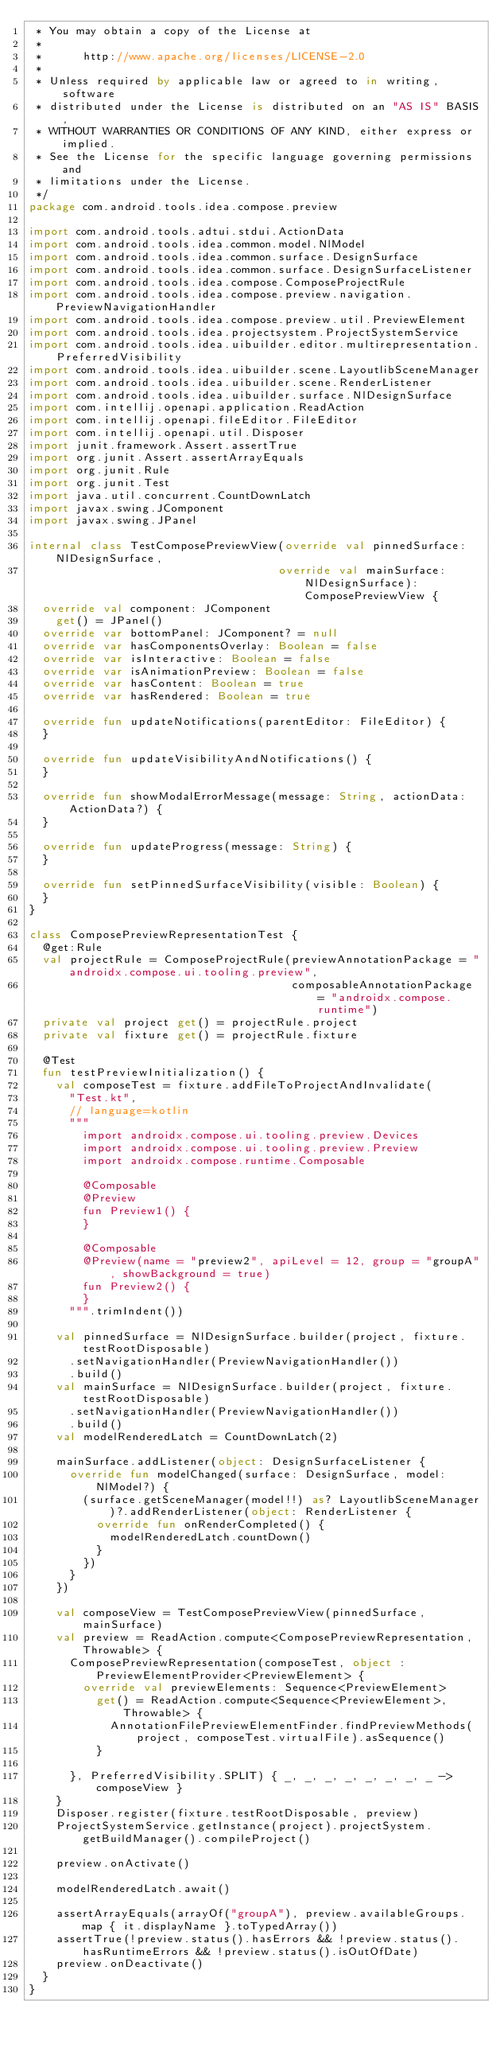Convert code to text. <code><loc_0><loc_0><loc_500><loc_500><_Kotlin_> * You may obtain a copy of the License at
 *
 *      http://www.apache.org/licenses/LICENSE-2.0
 *
 * Unless required by applicable law or agreed to in writing, software
 * distributed under the License is distributed on an "AS IS" BASIS,
 * WITHOUT WARRANTIES OR CONDITIONS OF ANY KIND, either express or implied.
 * See the License for the specific language governing permissions and
 * limitations under the License.
 */
package com.android.tools.idea.compose.preview

import com.android.tools.adtui.stdui.ActionData
import com.android.tools.idea.common.model.NlModel
import com.android.tools.idea.common.surface.DesignSurface
import com.android.tools.idea.common.surface.DesignSurfaceListener
import com.android.tools.idea.compose.ComposeProjectRule
import com.android.tools.idea.compose.preview.navigation.PreviewNavigationHandler
import com.android.tools.idea.compose.preview.util.PreviewElement
import com.android.tools.idea.projectsystem.ProjectSystemService
import com.android.tools.idea.uibuilder.editor.multirepresentation.PreferredVisibility
import com.android.tools.idea.uibuilder.scene.LayoutlibSceneManager
import com.android.tools.idea.uibuilder.scene.RenderListener
import com.android.tools.idea.uibuilder.surface.NlDesignSurface
import com.intellij.openapi.application.ReadAction
import com.intellij.openapi.fileEditor.FileEditor
import com.intellij.openapi.util.Disposer
import junit.framework.Assert.assertTrue
import org.junit.Assert.assertArrayEquals
import org.junit.Rule
import org.junit.Test
import java.util.concurrent.CountDownLatch
import javax.swing.JComponent
import javax.swing.JPanel

internal class TestComposePreviewView(override val pinnedSurface: NlDesignSurface,
                                     override val mainSurface: NlDesignSurface): ComposePreviewView {
  override val component: JComponent
    get() = JPanel()
  override var bottomPanel: JComponent? = null
  override var hasComponentsOverlay: Boolean = false
  override var isInteractive: Boolean = false
  override var isAnimationPreview: Boolean = false
  override var hasContent: Boolean = true
  override var hasRendered: Boolean = true

  override fun updateNotifications(parentEditor: FileEditor) {
  }

  override fun updateVisibilityAndNotifications() {
  }

  override fun showModalErrorMessage(message: String, actionData: ActionData?) {
  }

  override fun updateProgress(message: String) {
  }

  override fun setPinnedSurfaceVisibility(visible: Boolean) {
  }
}

class ComposePreviewRepresentationTest {
  @get:Rule
  val projectRule = ComposeProjectRule(previewAnnotationPackage = "androidx.compose.ui.tooling.preview",
                                       composableAnnotationPackage = "androidx.compose.runtime")
  private val project get() = projectRule.project
  private val fixture get() = projectRule.fixture

  @Test
  fun testPreviewInitialization() {
    val composeTest = fixture.addFileToProjectAndInvalidate(
      "Test.kt",
      // language=kotlin
      """
        import androidx.compose.ui.tooling.preview.Devices
        import androidx.compose.ui.tooling.preview.Preview
        import androidx.compose.runtime.Composable

        @Composable
        @Preview
        fun Preview1() {
        }

        @Composable
        @Preview(name = "preview2", apiLevel = 12, group = "groupA", showBackground = true)
        fun Preview2() {
        }
      """.trimIndent())

    val pinnedSurface = NlDesignSurface.builder(project, fixture.testRootDisposable)
      .setNavigationHandler(PreviewNavigationHandler())
      .build()
    val mainSurface = NlDesignSurface.builder(project, fixture.testRootDisposable)
      .setNavigationHandler(PreviewNavigationHandler())
      .build()
    val modelRenderedLatch = CountDownLatch(2)

    mainSurface.addListener(object: DesignSurfaceListener {
      override fun modelChanged(surface: DesignSurface, model: NlModel?) {
        (surface.getSceneManager(model!!) as? LayoutlibSceneManager)?.addRenderListener(object: RenderListener {
          override fun onRenderCompleted() {
            modelRenderedLatch.countDown()
          }
        })
      }
    })

    val composeView = TestComposePreviewView(pinnedSurface, mainSurface)
    val preview = ReadAction.compute<ComposePreviewRepresentation, Throwable> {
      ComposePreviewRepresentation(composeTest, object : PreviewElementProvider<PreviewElement> {
        override val previewElements: Sequence<PreviewElement>
          get() = ReadAction.compute<Sequence<PreviewElement>, Throwable> {
            AnnotationFilePreviewElementFinder.findPreviewMethods(project, composeTest.virtualFile).asSequence()
          }

      }, PreferredVisibility.SPLIT) { _, _, _, _, _, _, _, _ -> composeView }
    }
    Disposer.register(fixture.testRootDisposable, preview)
    ProjectSystemService.getInstance(project).projectSystem.getBuildManager().compileProject()

    preview.onActivate()

    modelRenderedLatch.await()

    assertArrayEquals(arrayOf("groupA"), preview.availableGroups.map { it.displayName }.toTypedArray())
    assertTrue(!preview.status().hasErrors && !preview.status().hasRuntimeErrors && !preview.status().isOutOfDate)
    preview.onDeactivate()
  }
}</code> 